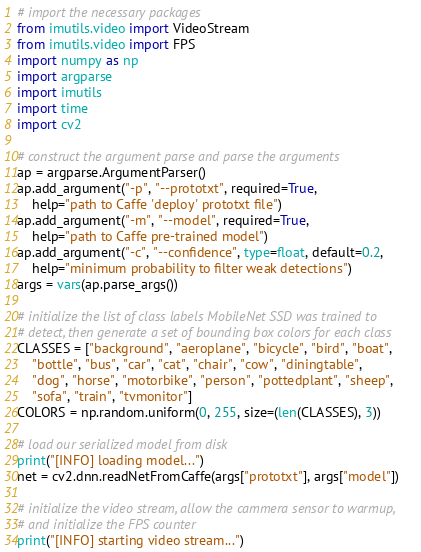<code> <loc_0><loc_0><loc_500><loc_500><_Python_># import the necessary packages
from imutils.video import VideoStream
from imutils.video import FPS
import numpy as np
import argparse
import imutils
import time
import cv2

# construct the argument parse and parse the arguments
ap = argparse.ArgumentParser()
ap.add_argument("-p", "--prototxt", required=True,
	help="path to Caffe 'deploy' prototxt file")
ap.add_argument("-m", "--model", required=True,
	help="path to Caffe pre-trained model")
ap.add_argument("-c", "--confidence", type=float, default=0.2,
	help="minimum probability to filter weak detections")
args = vars(ap.parse_args())

# initialize the list of class labels MobileNet SSD was trained to
# detect, then generate a set of bounding box colors for each class
CLASSES = ["background", "aeroplane", "bicycle", "bird", "boat",
	"bottle", "bus", "car", "cat", "chair", "cow", "diningtable",
	"dog", "horse", "motorbike", "person", "pottedplant", "sheep",
	"sofa", "train", "tvmonitor"]
COLORS = np.random.uniform(0, 255, size=(len(CLASSES), 3))

# load our serialized model from disk
print("[INFO] loading model...")
net = cv2.dnn.readNetFromCaffe(args["prototxt"], args["model"])

# initialize the video stream, allow the cammera sensor to warmup,
# and initialize the FPS counter
print("[INFO] starting video stream...")</code> 